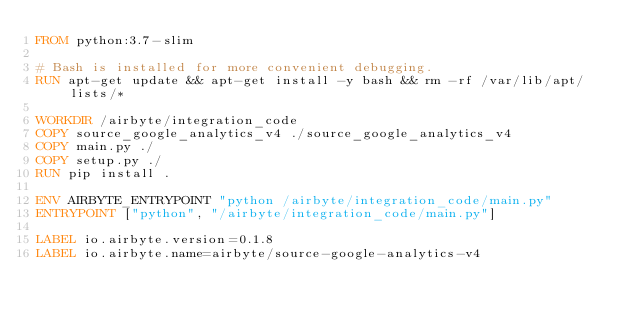<code> <loc_0><loc_0><loc_500><loc_500><_Dockerfile_>FROM python:3.7-slim

# Bash is installed for more convenient debugging.
RUN apt-get update && apt-get install -y bash && rm -rf /var/lib/apt/lists/*

WORKDIR /airbyte/integration_code
COPY source_google_analytics_v4 ./source_google_analytics_v4
COPY main.py ./
COPY setup.py ./
RUN pip install .

ENV AIRBYTE_ENTRYPOINT "python /airbyte/integration_code/main.py"
ENTRYPOINT ["python", "/airbyte/integration_code/main.py"]

LABEL io.airbyte.version=0.1.8
LABEL io.airbyte.name=airbyte/source-google-analytics-v4
</code> 